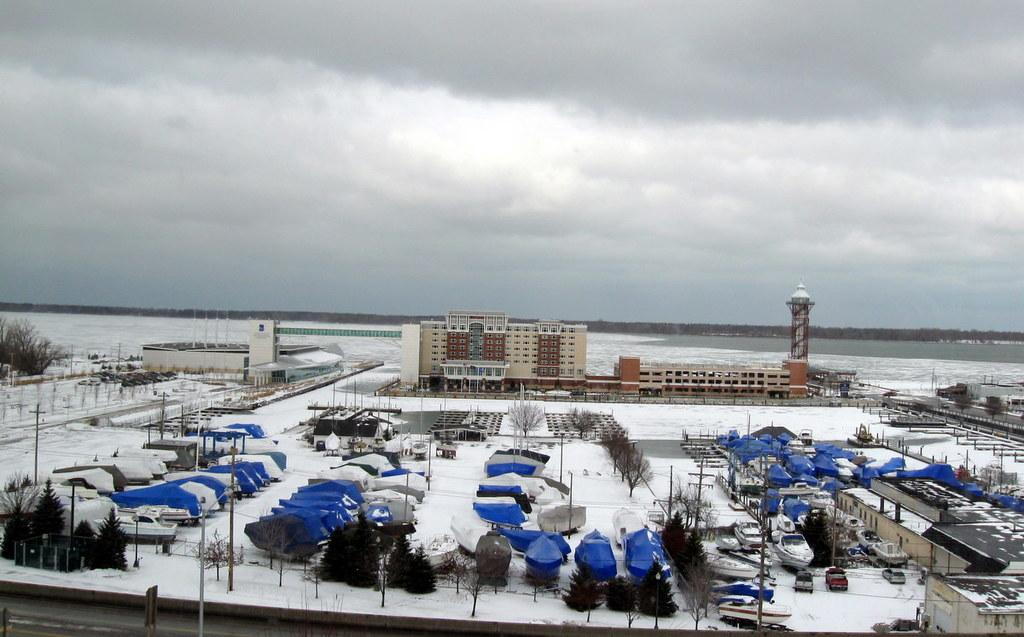What can be seen at the bottom of the image? There are trees, boats, vehicles, and buildings at the bottom of the image. What is the ground covered with at the bottom of the image? There is snow on the ground at the bottom of the image. What is visible in the background of the image? There are trees and clouds in the sky in the background of the image. Can you see a rat shaking a picture in the image? There is no rat or picture present in the image. What type of picture is the rat shaking in the image? There is no rat or picture present in the image, so it is not possible to answer that question. 